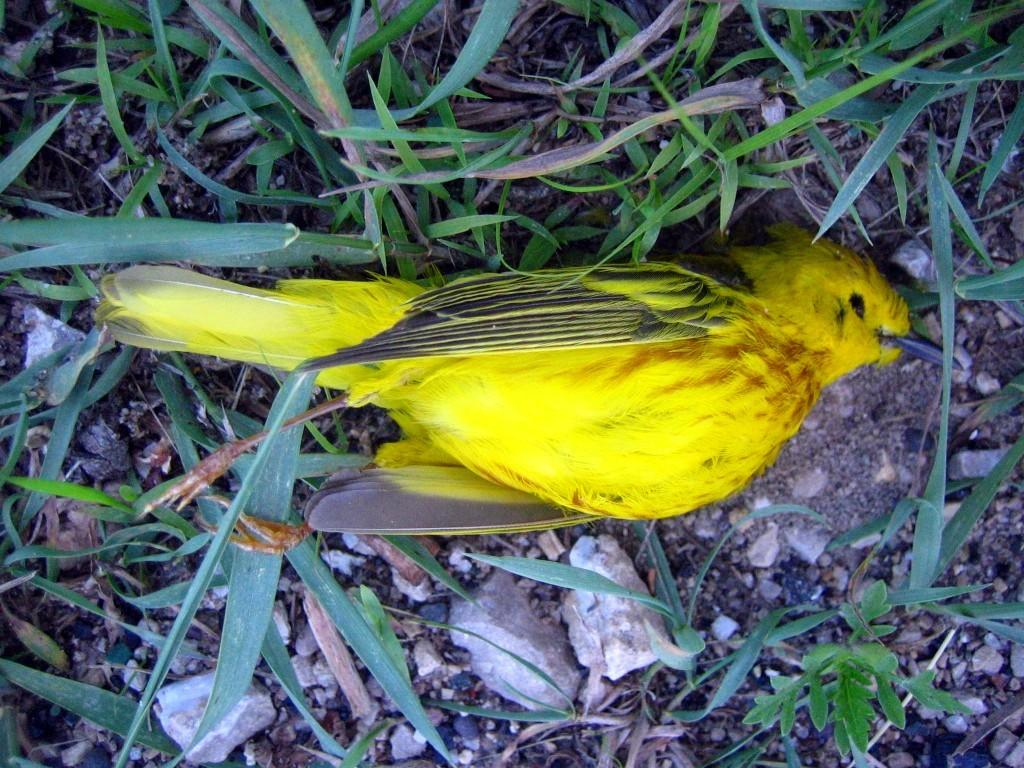What type of animal is on the ground in the image? There is a bird on the ground in the image. What type of vegetation can be seen in the image? There is grass visible in the image. What type of inanimate objects are present in the image? There are stones in the image. What type of bomb can be seen in the image? There is no bomb present in the image. How many oranges are visible in the image? There are no oranges present in the image. 